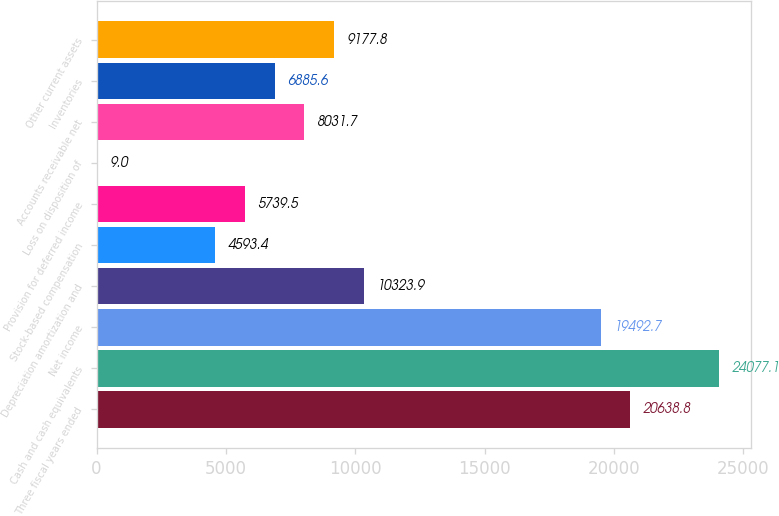Convert chart to OTSL. <chart><loc_0><loc_0><loc_500><loc_500><bar_chart><fcel>Three fiscal years ended<fcel>Cash and cash equivalents<fcel>Net income<fcel>Depreciation amortization and<fcel>Stock-based compensation<fcel>Provision for deferred income<fcel>Loss on disposition of<fcel>Accounts receivable net<fcel>Inventories<fcel>Other current assets<nl><fcel>20638.8<fcel>24077.1<fcel>19492.7<fcel>10323.9<fcel>4593.4<fcel>5739.5<fcel>9<fcel>8031.7<fcel>6885.6<fcel>9177.8<nl></chart> 